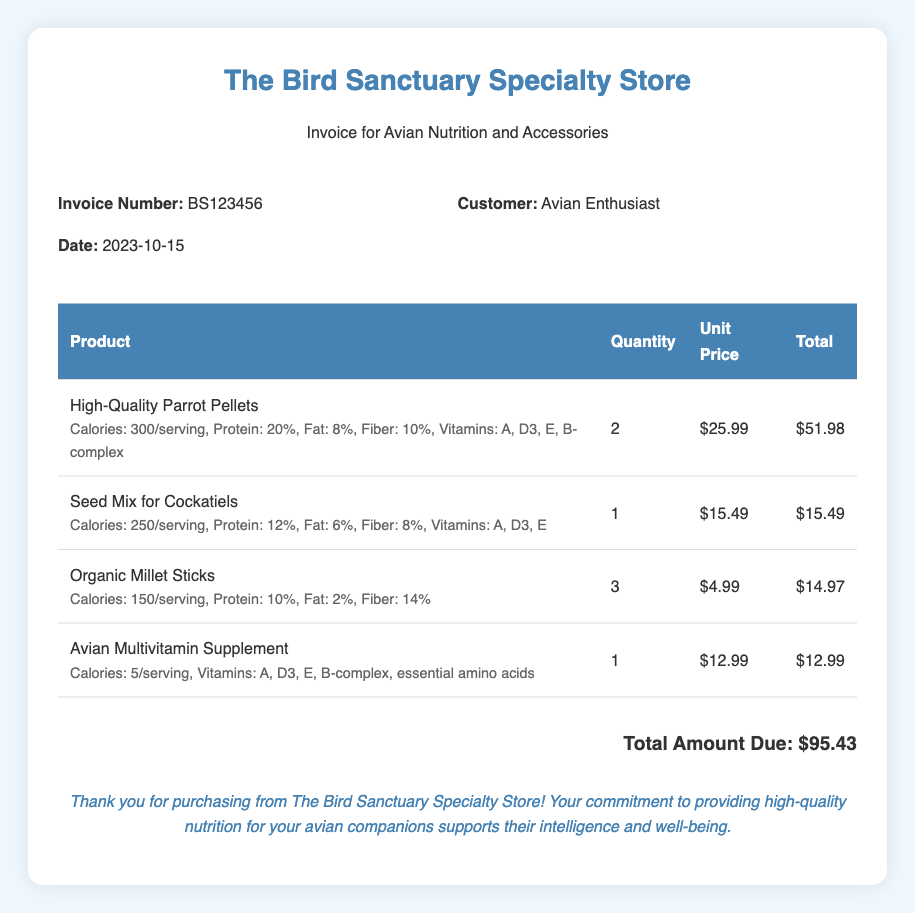What is the invoice number? The invoice number is prominently displayed in the document, listed in the invoice details section.
Answer: BS123456 What is the date of the invoice? The date is specified in the invoice details section, indicating when the transaction occurred.
Answer: 2023-10-15 Who is the customer? The customer's name is provided in the invoice details, identifying who made the purchase.
Answer: Avian Enthusiast How many units of High-Quality Parrot Pellets were purchased? The quantity of High-Quality Parrot Pellets is itemized in the product list of the invoice.
Answer: 2 What is the total amount due? The total amount due is calculated based on the sum of all products listed in the invoice.
Answer: $95.43 What types of vitamins are included in the Avian Multivitamin Supplement? The nutritional information section for the Avian Multivitamin Supplement lists the vitamins contained within it.
Answer: A, D3, E, B-complex Which product has the highest unit price? By evaluating the unit prices of all listed products, the one with the highest cost can be identified.
Answer: High-Quality Parrot Pellets What is the total quantity of Organic Millet Sticks purchased? The document specifies the quantity of each product in the respective line items.
Answer: 3 What is the primary focus of The Bird Sanctuary Specialty Store as indicated in the thank-you note? The thank-you note emphasizes the importance of providing high-quality nutrition for avian companions, which reflects the store's mission.
Answer: Nutrition 